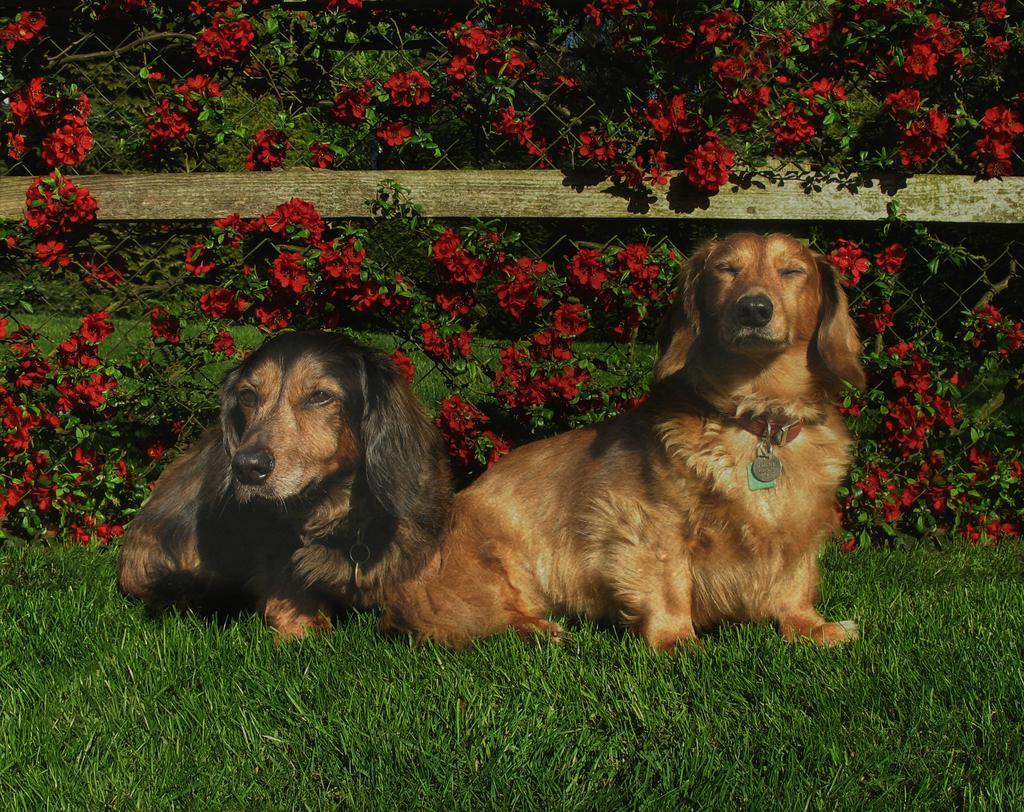Describe this image in one or two sentences. We can see dogs on the grass, behind these dogs we can see flowers and leaves on mesh, through this mess we can see trees. 